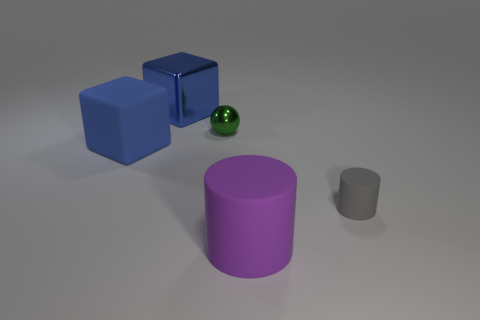Add 3 tiny blue things. How many objects exist? 8 Subtract all cubes. How many objects are left? 3 Add 1 tiny matte cylinders. How many tiny matte cylinders are left? 2 Add 4 cubes. How many cubes exist? 6 Subtract 0 purple blocks. How many objects are left? 5 Subtract all tiny green rubber blocks. Subtract all rubber cylinders. How many objects are left? 3 